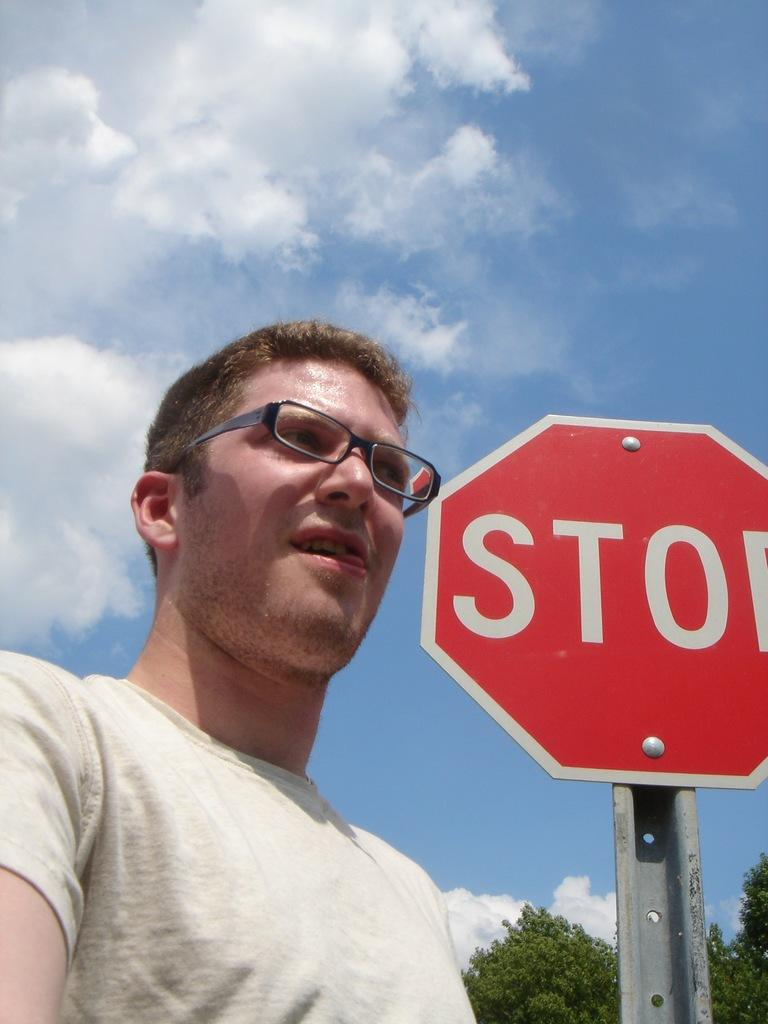<image>
Summarize the visual content of the image. A young man wearing glasses and standing next to a stop sign. 